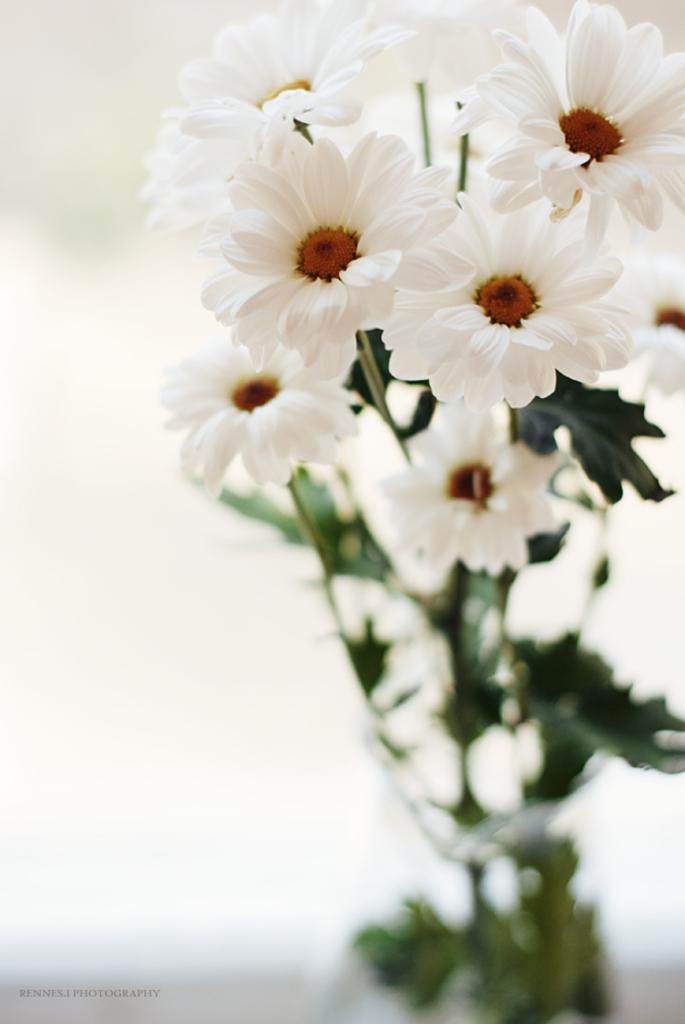What type of flowers are in the vase in the image? There are white flowers in the vase in the image. How would you describe the overall clarity of the image? The image is slightly blurred. What color is the background of the image? The background of the image is white. Can you identify any text in the image? Yes, there is edited text in the image. Where are the dolls placed in the image? There are no dolls present in the image. What type of fruit is being boiled in the kettle in the image? There is no kettle or fruit present in the image. 